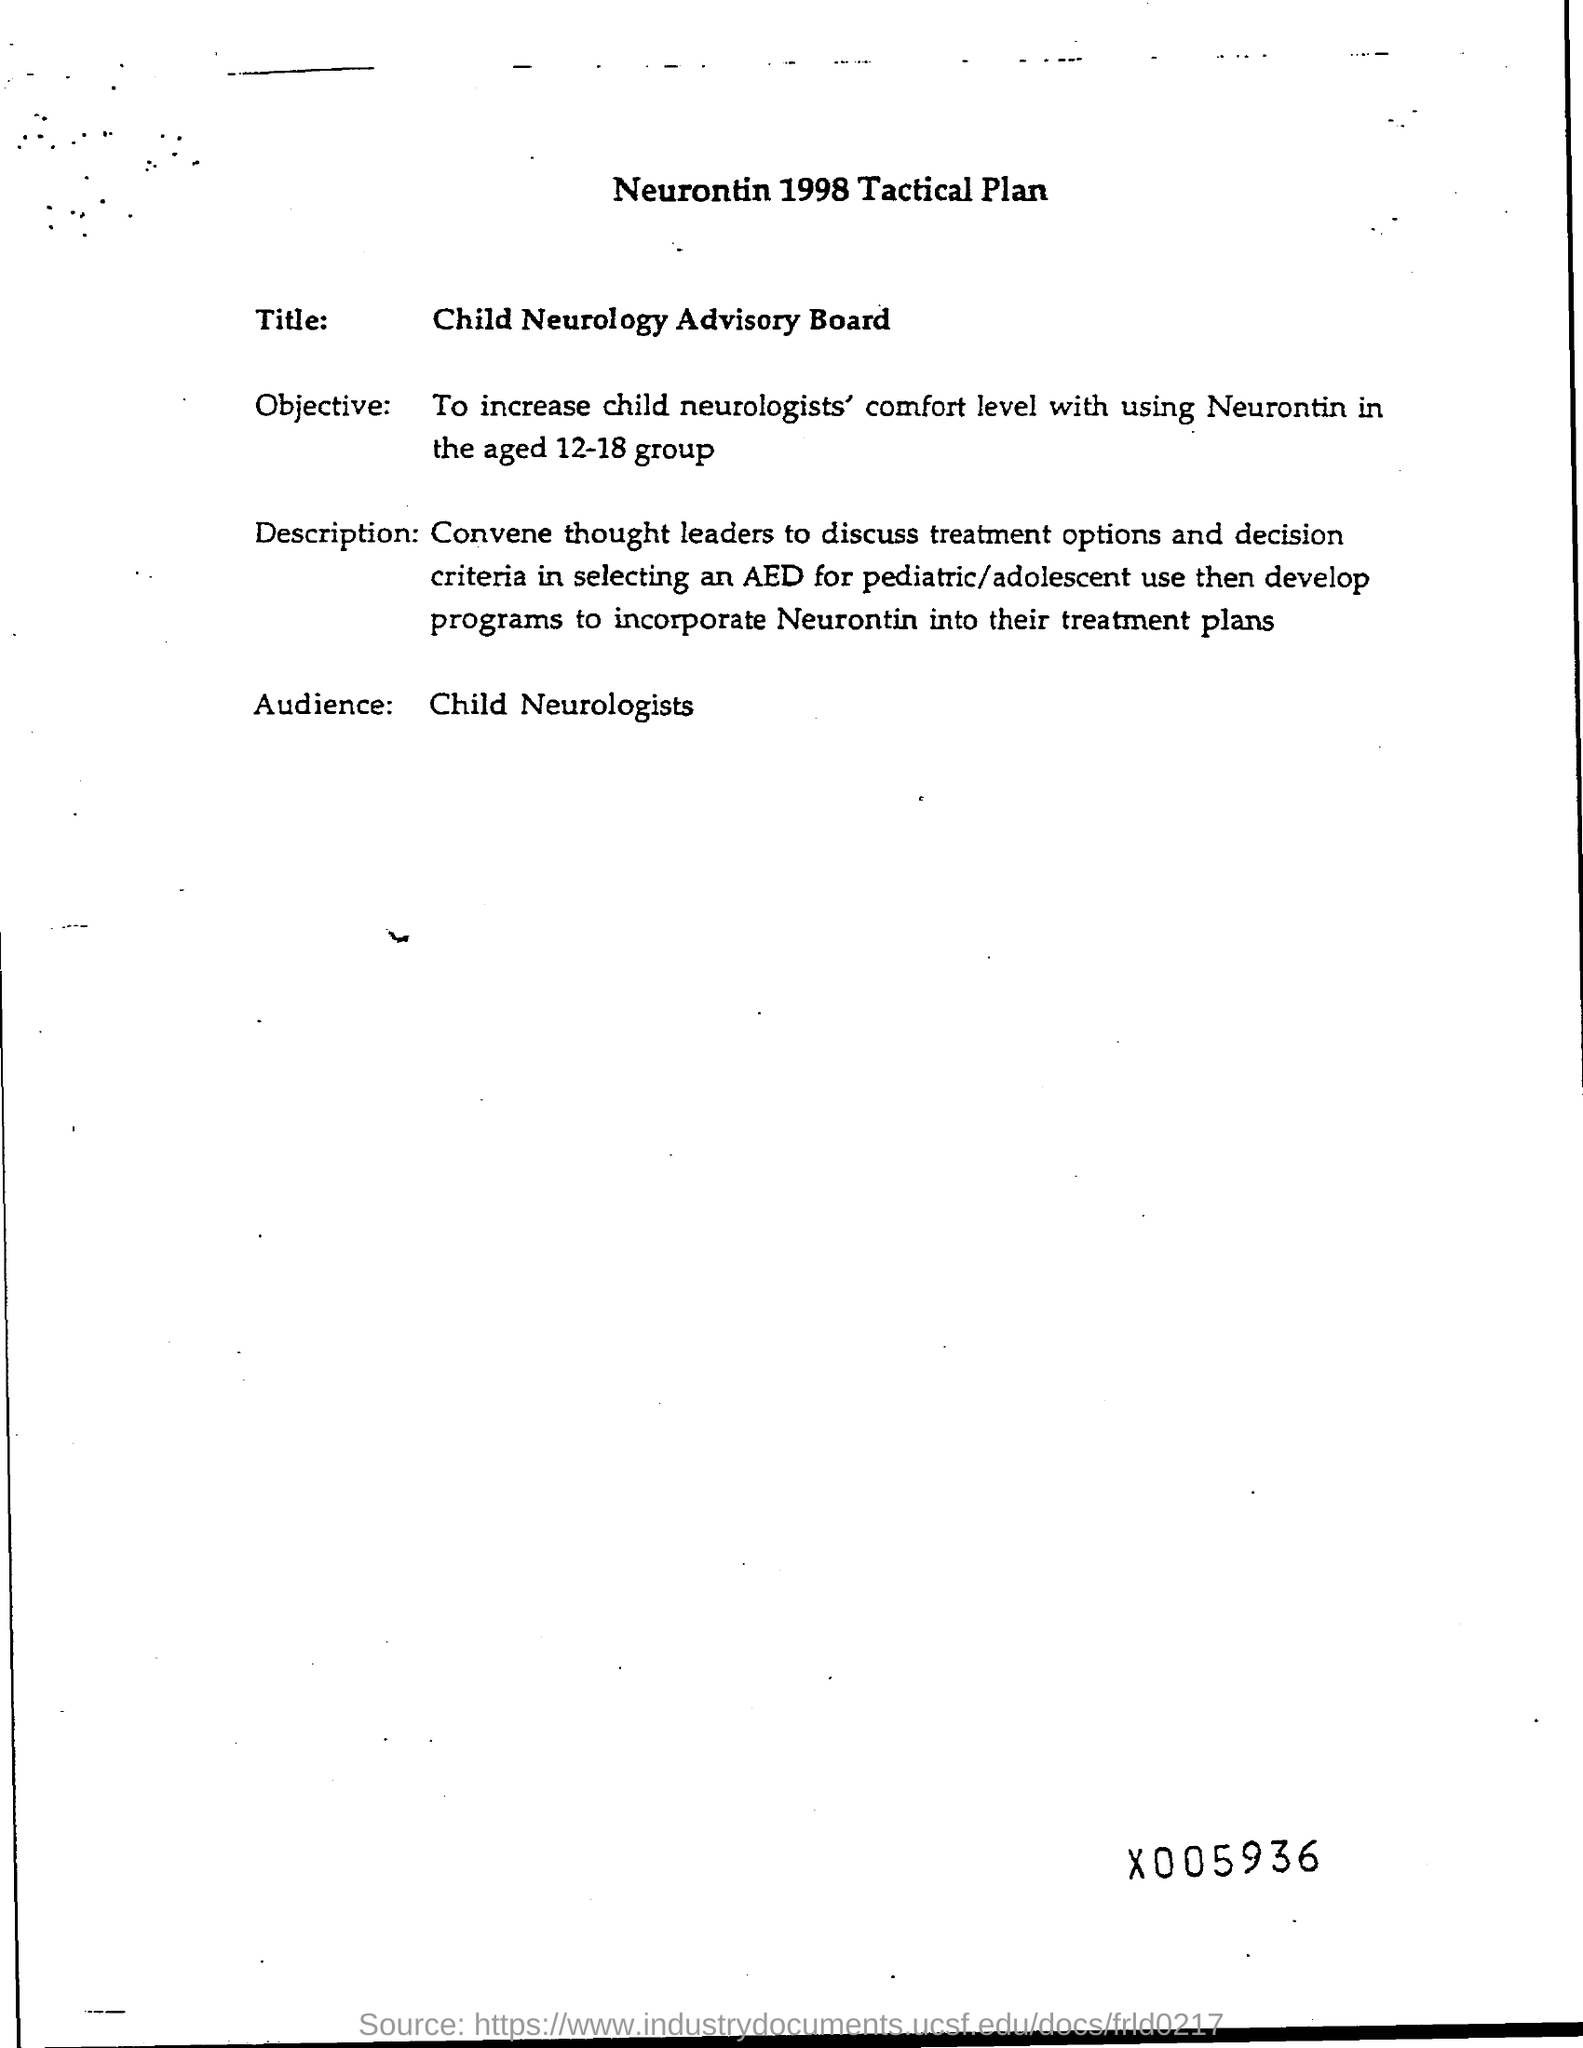What is the title of the page ?
Your response must be concise. Neurontin 1998 tactical plan. What is the title ?
Your response must be concise. Child neurology advisory board. Who are audience ?
Offer a very short reply. Child Neurologists. 